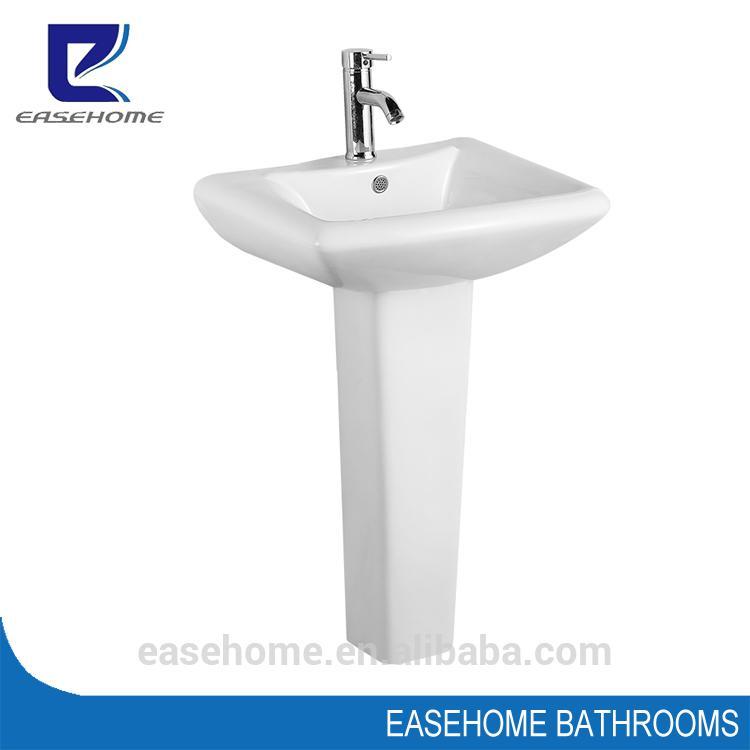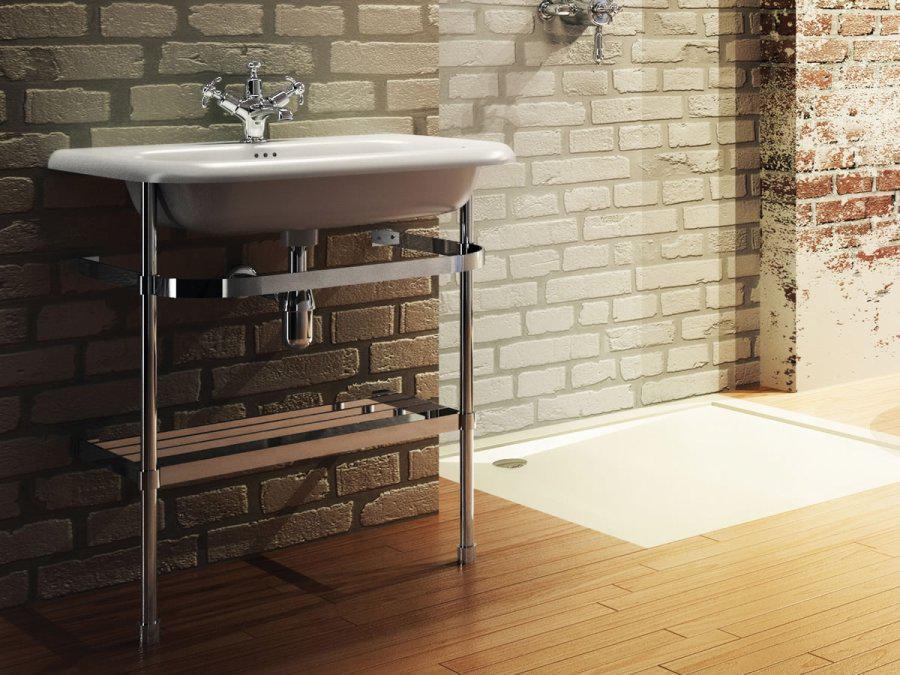The first image is the image on the left, the second image is the image on the right. Evaluate the accuracy of this statement regarding the images: "There is a sink on a pillar in a room, with a mirror above it.". Is it true? Answer yes or no. No. The first image is the image on the left, the second image is the image on the right. Examine the images to the left and right. Is the description "A toilet is sitting in a room with a white baseboard in one of the images." accurate? Answer yes or no. No. 